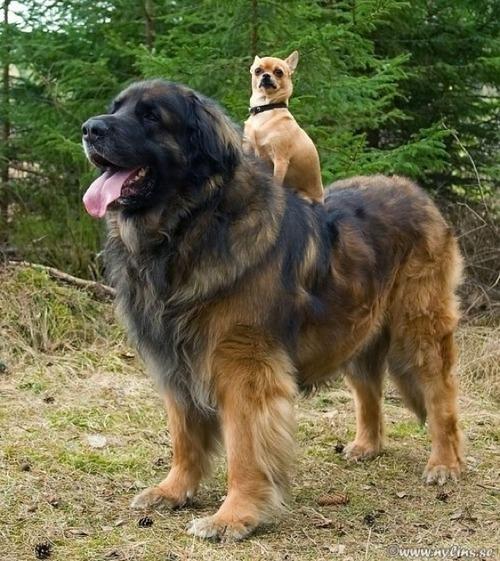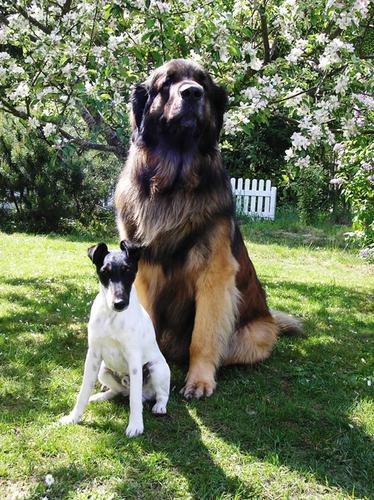The first image is the image on the left, the second image is the image on the right. For the images shown, is this caption "At least one of the dogs in the image on the left is shown standing up on the ground." true? Answer yes or no. Yes. The first image is the image on the left, the second image is the image on the right. Given the left and right images, does the statement "One image contains just one dog, which is standing on all fours." hold true? Answer yes or no. No. 